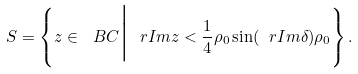<formula> <loc_0><loc_0><loc_500><loc_500>S = \left \{ z \in \ B C \Big | \ r I m z < { \frac { 1 } { 4 } } \rho _ { 0 } \sin ( \ r I m \delta ) \rho _ { 0 } \right \} .</formula> 